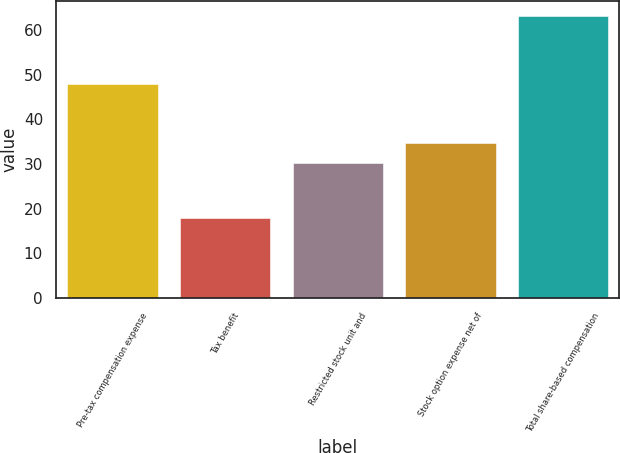<chart> <loc_0><loc_0><loc_500><loc_500><bar_chart><fcel>Pre-tax compensation expense<fcel>Tax benefit<fcel>Restricted stock unit and<fcel>Stock option expense net of<fcel>Total share-based compensation<nl><fcel>47.9<fcel>17.8<fcel>30.1<fcel>34.64<fcel>63.2<nl></chart> 